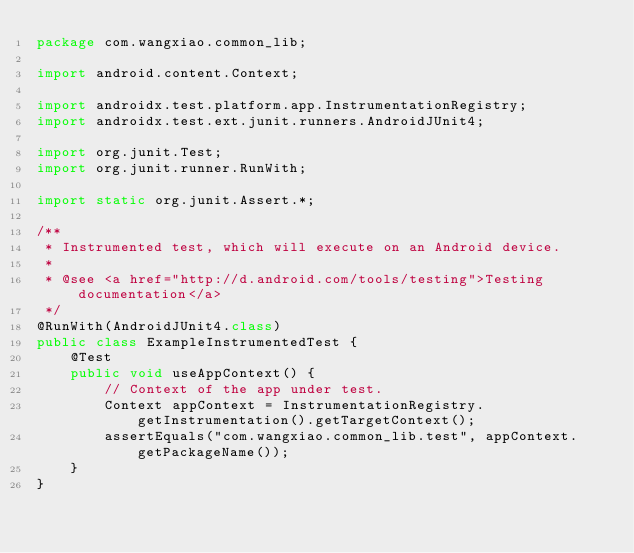Convert code to text. <code><loc_0><loc_0><loc_500><loc_500><_Java_>package com.wangxiao.common_lib;

import android.content.Context;

import androidx.test.platform.app.InstrumentationRegistry;
import androidx.test.ext.junit.runners.AndroidJUnit4;

import org.junit.Test;
import org.junit.runner.RunWith;

import static org.junit.Assert.*;

/**
 * Instrumented test, which will execute on an Android device.
 *
 * @see <a href="http://d.android.com/tools/testing">Testing documentation</a>
 */
@RunWith(AndroidJUnit4.class)
public class ExampleInstrumentedTest {
    @Test
    public void useAppContext() {
        // Context of the app under test.
        Context appContext = InstrumentationRegistry.getInstrumentation().getTargetContext();
        assertEquals("com.wangxiao.common_lib.test", appContext.getPackageName());
    }
}</code> 